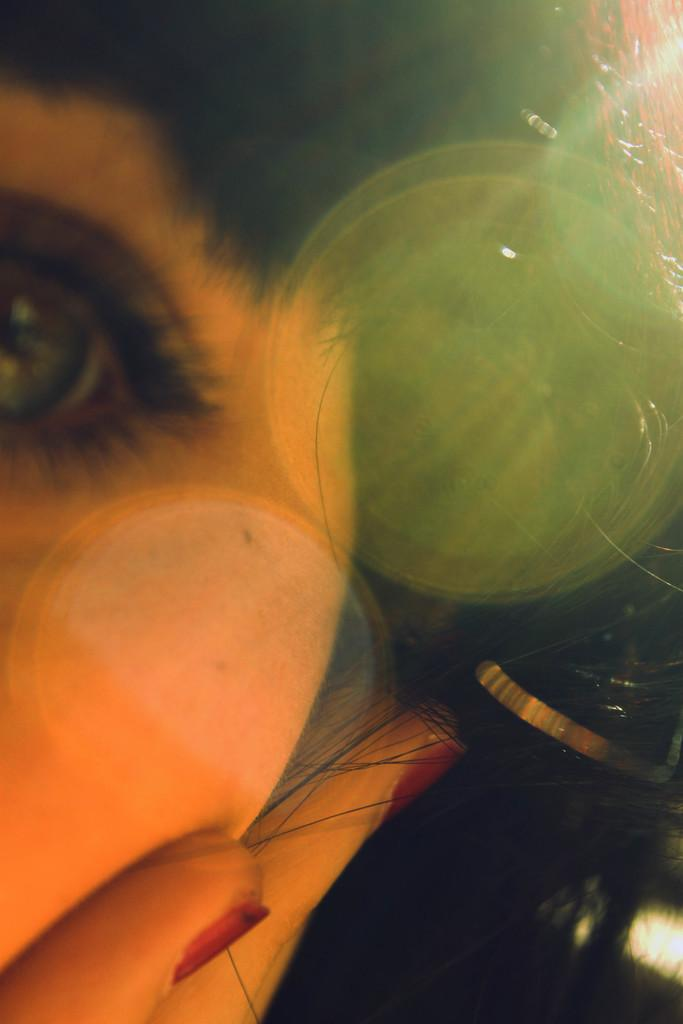What body part is the main focus of the image? The main focus of the image is a human eye. What other body part is visible in the image? A human hand is also visible in the image. Where are the eye and hand located in relation to each other? Both the eye and hand are on a person's face. What type of shoe is visible in the image? There is no shoe present in the image. Can you describe the fish swimming near the person's face in the image? There is no fish present in the image; it only features a human eye and hand on a person's face. 